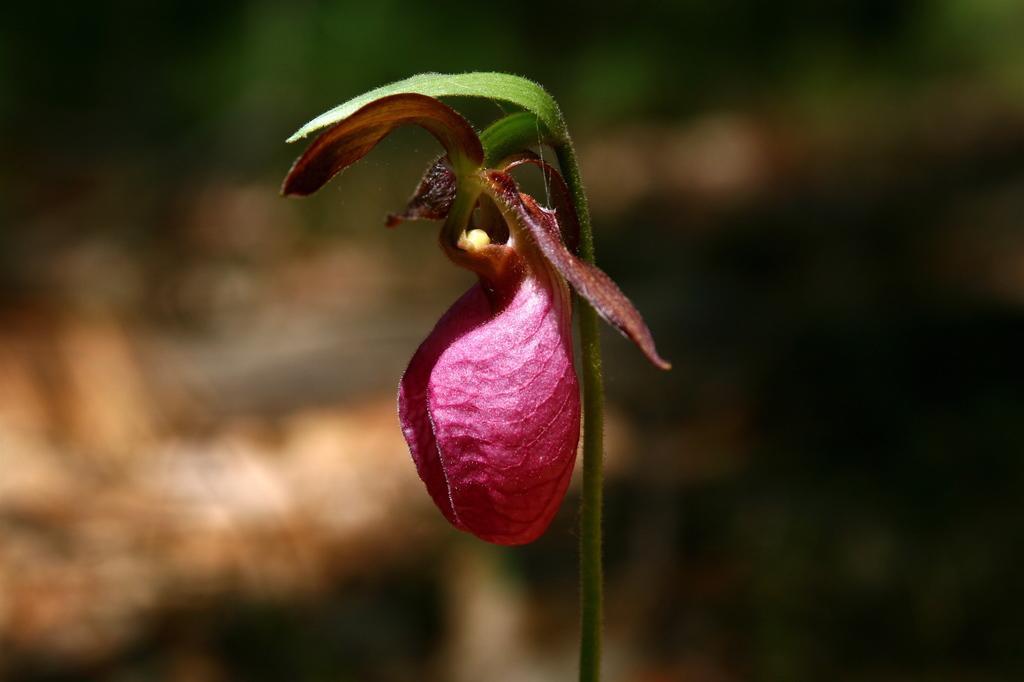Please provide a concise description of this image. In this picture, we see a plant which has a flower. This flower is in pink color. In the background, it is in black color. This picture is blurred in the background. 